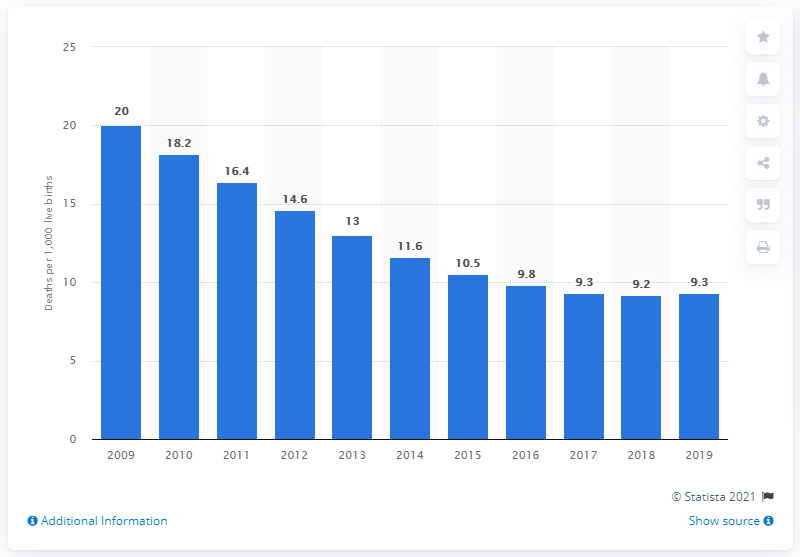Give some essential details in this illustration. According to data from 2019, the infant mortality rate in Kazakhstan was 9.3 deaths per 1,000 live births. This represents a significant decrease from the previous year and demonstrates the country's ongoing efforts to improve public health and reduce infant mortality rates. 